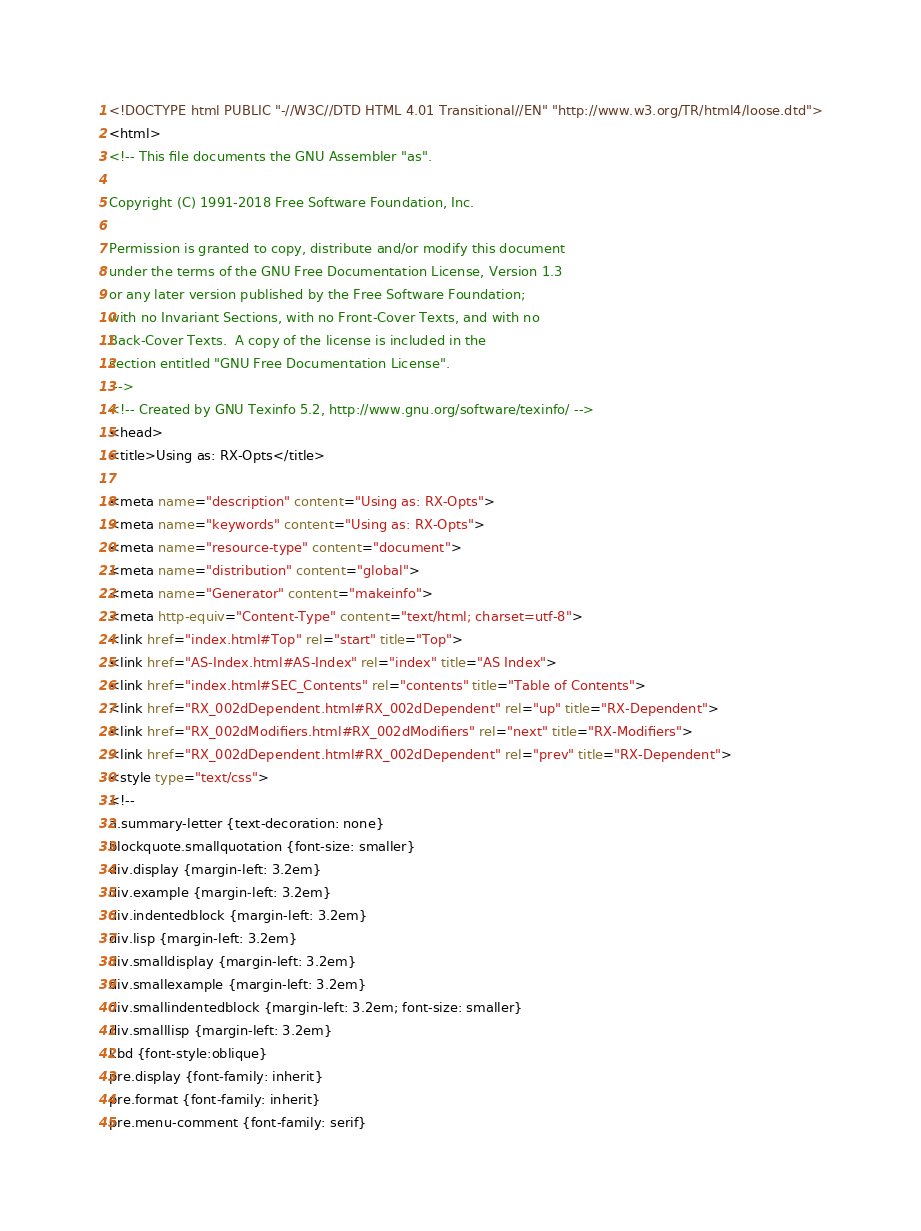<code> <loc_0><loc_0><loc_500><loc_500><_HTML_><!DOCTYPE html PUBLIC "-//W3C//DTD HTML 4.01 Transitional//EN" "http://www.w3.org/TR/html4/loose.dtd">
<html>
<!-- This file documents the GNU Assembler "as".

Copyright (C) 1991-2018 Free Software Foundation, Inc.

Permission is granted to copy, distribute and/or modify this document
under the terms of the GNU Free Documentation License, Version 1.3
or any later version published by the Free Software Foundation;
with no Invariant Sections, with no Front-Cover Texts, and with no
Back-Cover Texts.  A copy of the license is included in the
section entitled "GNU Free Documentation License".
 -->
<!-- Created by GNU Texinfo 5.2, http://www.gnu.org/software/texinfo/ -->
<head>
<title>Using as: RX-Opts</title>

<meta name="description" content="Using as: RX-Opts">
<meta name="keywords" content="Using as: RX-Opts">
<meta name="resource-type" content="document">
<meta name="distribution" content="global">
<meta name="Generator" content="makeinfo">
<meta http-equiv="Content-Type" content="text/html; charset=utf-8">
<link href="index.html#Top" rel="start" title="Top">
<link href="AS-Index.html#AS-Index" rel="index" title="AS Index">
<link href="index.html#SEC_Contents" rel="contents" title="Table of Contents">
<link href="RX_002dDependent.html#RX_002dDependent" rel="up" title="RX-Dependent">
<link href="RX_002dModifiers.html#RX_002dModifiers" rel="next" title="RX-Modifiers">
<link href="RX_002dDependent.html#RX_002dDependent" rel="prev" title="RX-Dependent">
<style type="text/css">
<!--
a.summary-letter {text-decoration: none}
blockquote.smallquotation {font-size: smaller}
div.display {margin-left: 3.2em}
div.example {margin-left: 3.2em}
div.indentedblock {margin-left: 3.2em}
div.lisp {margin-left: 3.2em}
div.smalldisplay {margin-left: 3.2em}
div.smallexample {margin-left: 3.2em}
div.smallindentedblock {margin-left: 3.2em; font-size: smaller}
div.smalllisp {margin-left: 3.2em}
kbd {font-style:oblique}
pre.display {font-family: inherit}
pre.format {font-family: inherit}
pre.menu-comment {font-family: serif}</code> 